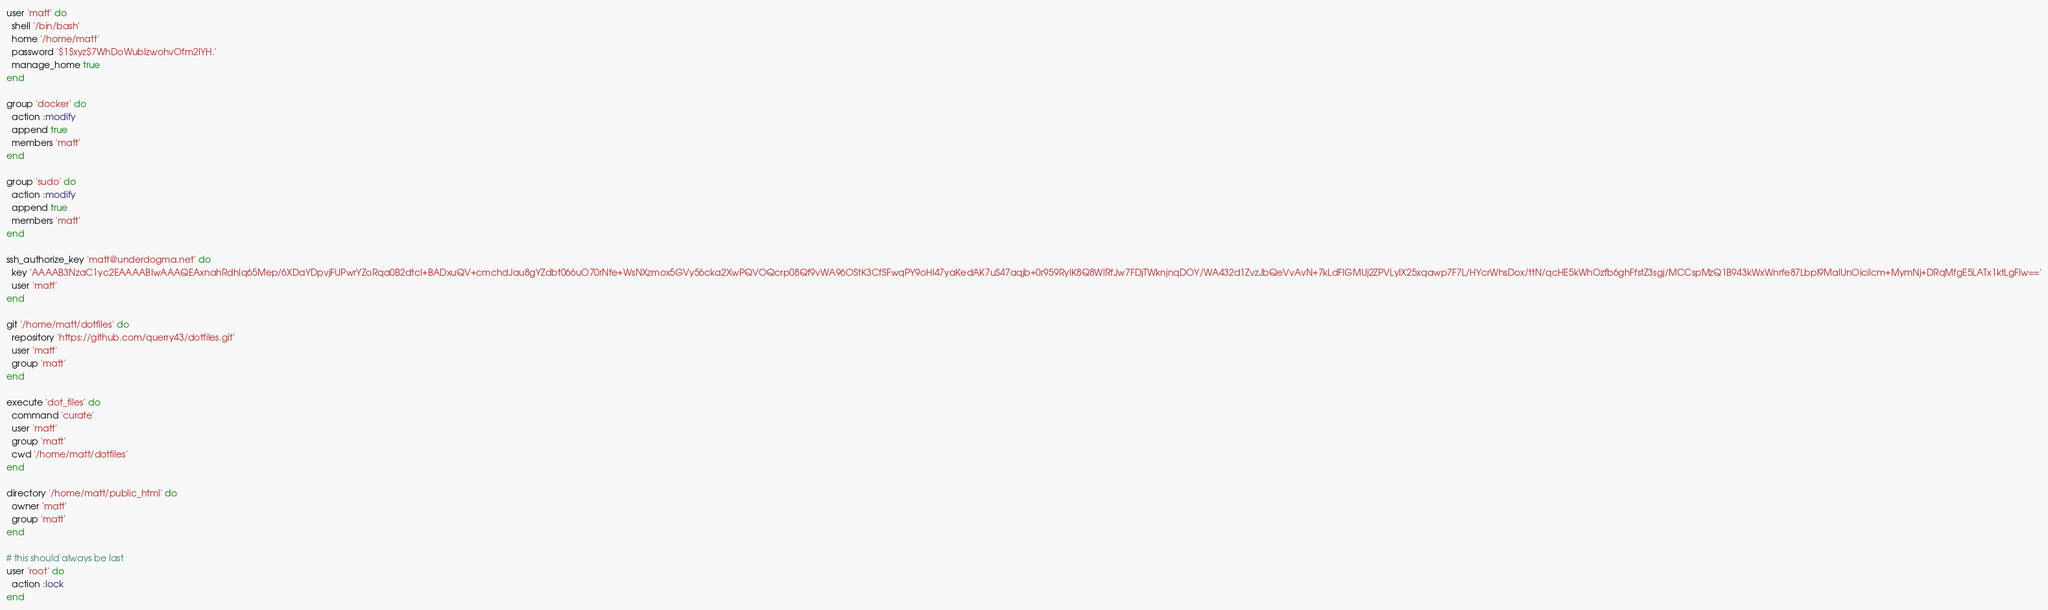<code> <loc_0><loc_0><loc_500><loc_500><_Ruby_>user 'matt' do
  shell '/bin/bash'
  home '/home/matt'
  password '$1$xyz$7WhDoWubIzwohvOfm2IYH.'
  manage_home true
end

group 'docker' do
  action :modify
  append true
  members 'matt'
end

group 'sudo' do
  action :modify
  append true
  members 'matt'
end

ssh_authorize_key 'matt@underdogma.net' do
  key 'AAAAB3NzaC1yc2EAAAABIwAAAQEAxnahRdhIq65Mep/6XDaYDpvjFUPwrYZoRqa0B2dtcI+BADxuQV+cmchdJau8gYZdbt066uO70rNfe+WsNXzmox5GVy56cka2XwPQVOQcrp08Qf9vWA96OStK3CfSFwqPY9oHl47yaKedAK7uS47aqjb+0r959RylK8Q8WlRfJw7FDjTWknjnqDOY/WA432d1ZvzJbQeVvAvN+7kLdFIGMUj2ZPVLyIX25xqawp7F7L/HYcrWhsDox/ttN/qcHE5kWhOzfb6ghFfstZ3sgj/MCCspMzQ1B943kWxWnrfe87Lbpl9MaIUnOicilcm+MymNj+DRqMfgE5LATx1ktLgFIw=='
  user 'matt'
end

git '/home/matt/dotfiles' do
  repository 'https://github.com/querry43/dotfiles.git'
  user 'matt'
  group 'matt'
end

execute 'dot_files' do
  command 'curate'
  user 'matt'
  group 'matt'
  cwd '/home/matt/dotfiles'
end

directory '/home/matt/public_html' do
  owner 'matt'
  group 'matt'
end

# this should always be last
user 'root' do
  action :lock
end
</code> 